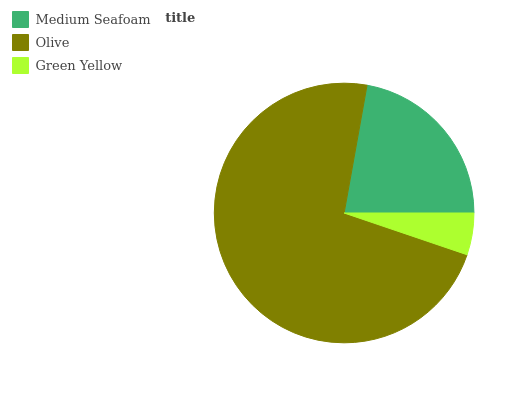Is Green Yellow the minimum?
Answer yes or no. Yes. Is Olive the maximum?
Answer yes or no. Yes. Is Olive the minimum?
Answer yes or no. No. Is Green Yellow the maximum?
Answer yes or no. No. Is Olive greater than Green Yellow?
Answer yes or no. Yes. Is Green Yellow less than Olive?
Answer yes or no. Yes. Is Green Yellow greater than Olive?
Answer yes or no. No. Is Olive less than Green Yellow?
Answer yes or no. No. Is Medium Seafoam the high median?
Answer yes or no. Yes. Is Medium Seafoam the low median?
Answer yes or no. Yes. Is Green Yellow the high median?
Answer yes or no. No. Is Olive the low median?
Answer yes or no. No. 